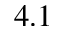Convert formula to latex. <formula><loc_0><loc_0><loc_500><loc_500>4 . 1</formula> 